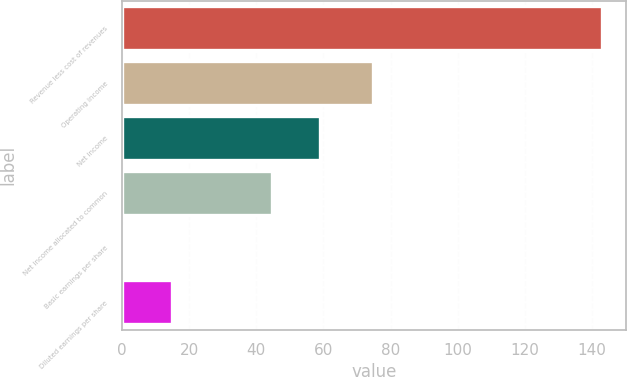Convert chart. <chart><loc_0><loc_0><loc_500><loc_500><bar_chart><fcel>Revenue less cost of revenues<fcel>Operating income<fcel>Net income<fcel>Net income allocated to common<fcel>Basic earnings per share<fcel>Diluted earnings per share<nl><fcel>143<fcel>74.9<fcel>58.95<fcel>44.7<fcel>0.55<fcel>14.79<nl></chart> 